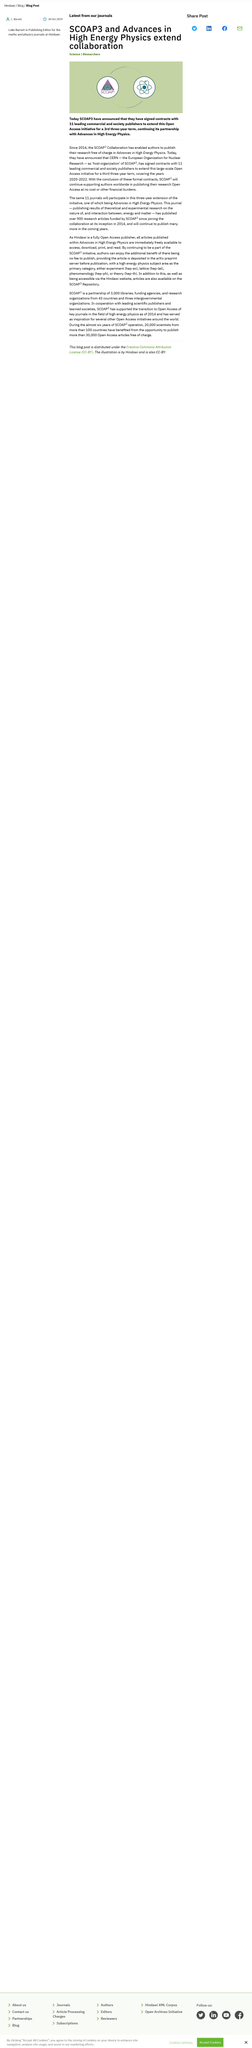Point out several critical features in this image. SCOAP has announced the extension of its Open Access initiative with Advances in High Energy Physics for a third three-year term. SCOAP's Open Access initiative will cover the years 2020, 2021, and 2022. SCOAP started enabling authors to publish their research in Advances in High Energy Physics free of charge in 2014. 